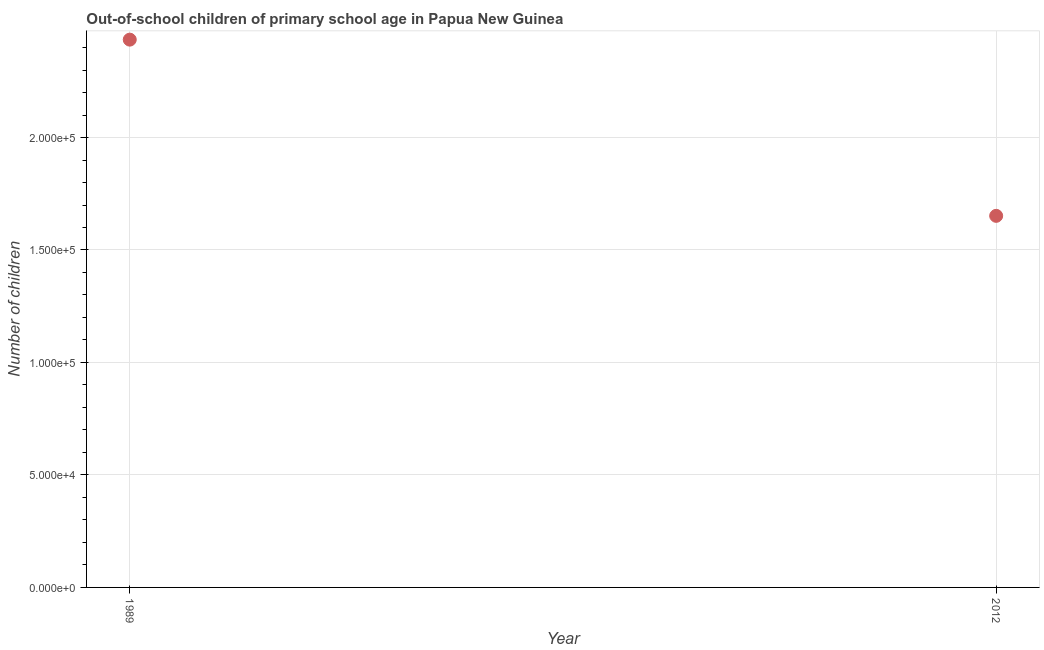What is the number of out-of-school children in 1989?
Offer a very short reply. 2.44e+05. Across all years, what is the maximum number of out-of-school children?
Your answer should be compact. 2.44e+05. Across all years, what is the minimum number of out-of-school children?
Make the answer very short. 1.65e+05. What is the sum of the number of out-of-school children?
Offer a terse response. 4.09e+05. What is the difference between the number of out-of-school children in 1989 and 2012?
Your answer should be compact. 7.83e+04. What is the average number of out-of-school children per year?
Your response must be concise. 2.04e+05. What is the median number of out-of-school children?
Your answer should be very brief. 2.04e+05. Do a majority of the years between 2012 and 1989 (inclusive) have number of out-of-school children greater than 70000 ?
Make the answer very short. No. What is the ratio of the number of out-of-school children in 1989 to that in 2012?
Provide a succinct answer. 1.47. In how many years, is the number of out-of-school children greater than the average number of out-of-school children taken over all years?
Your response must be concise. 1. Are the values on the major ticks of Y-axis written in scientific E-notation?
Offer a terse response. Yes. What is the title of the graph?
Provide a short and direct response. Out-of-school children of primary school age in Papua New Guinea. What is the label or title of the Y-axis?
Offer a very short reply. Number of children. What is the Number of children in 1989?
Offer a terse response. 2.44e+05. What is the Number of children in 2012?
Your answer should be very brief. 1.65e+05. What is the difference between the Number of children in 1989 and 2012?
Provide a succinct answer. 7.83e+04. What is the ratio of the Number of children in 1989 to that in 2012?
Provide a succinct answer. 1.47. 